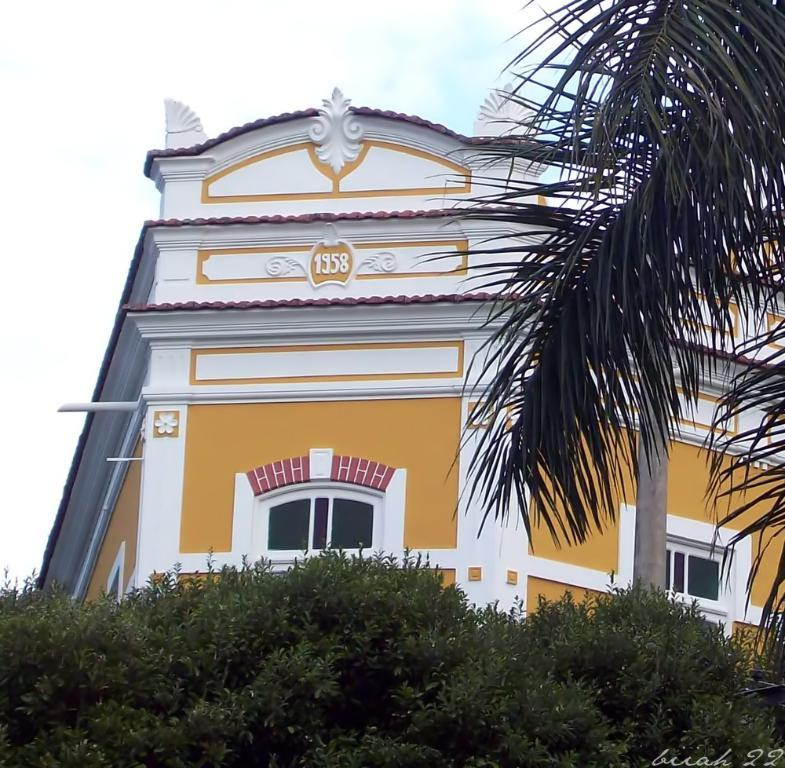What type of structure is present in the image? There is a house in the image. What features can be seen on the house? The house has windows. What type of vegetation is visible in the image? There are trees and plants in the image. What part of the natural environment is visible in the image? The sky is visible in the image. Is there any text present in the image? Yes, there is some text on the image. How many jellyfish are swimming in the sky in the image? There are no jellyfish present in the image, and the sky is not a body of water where jellyfish would be found. 